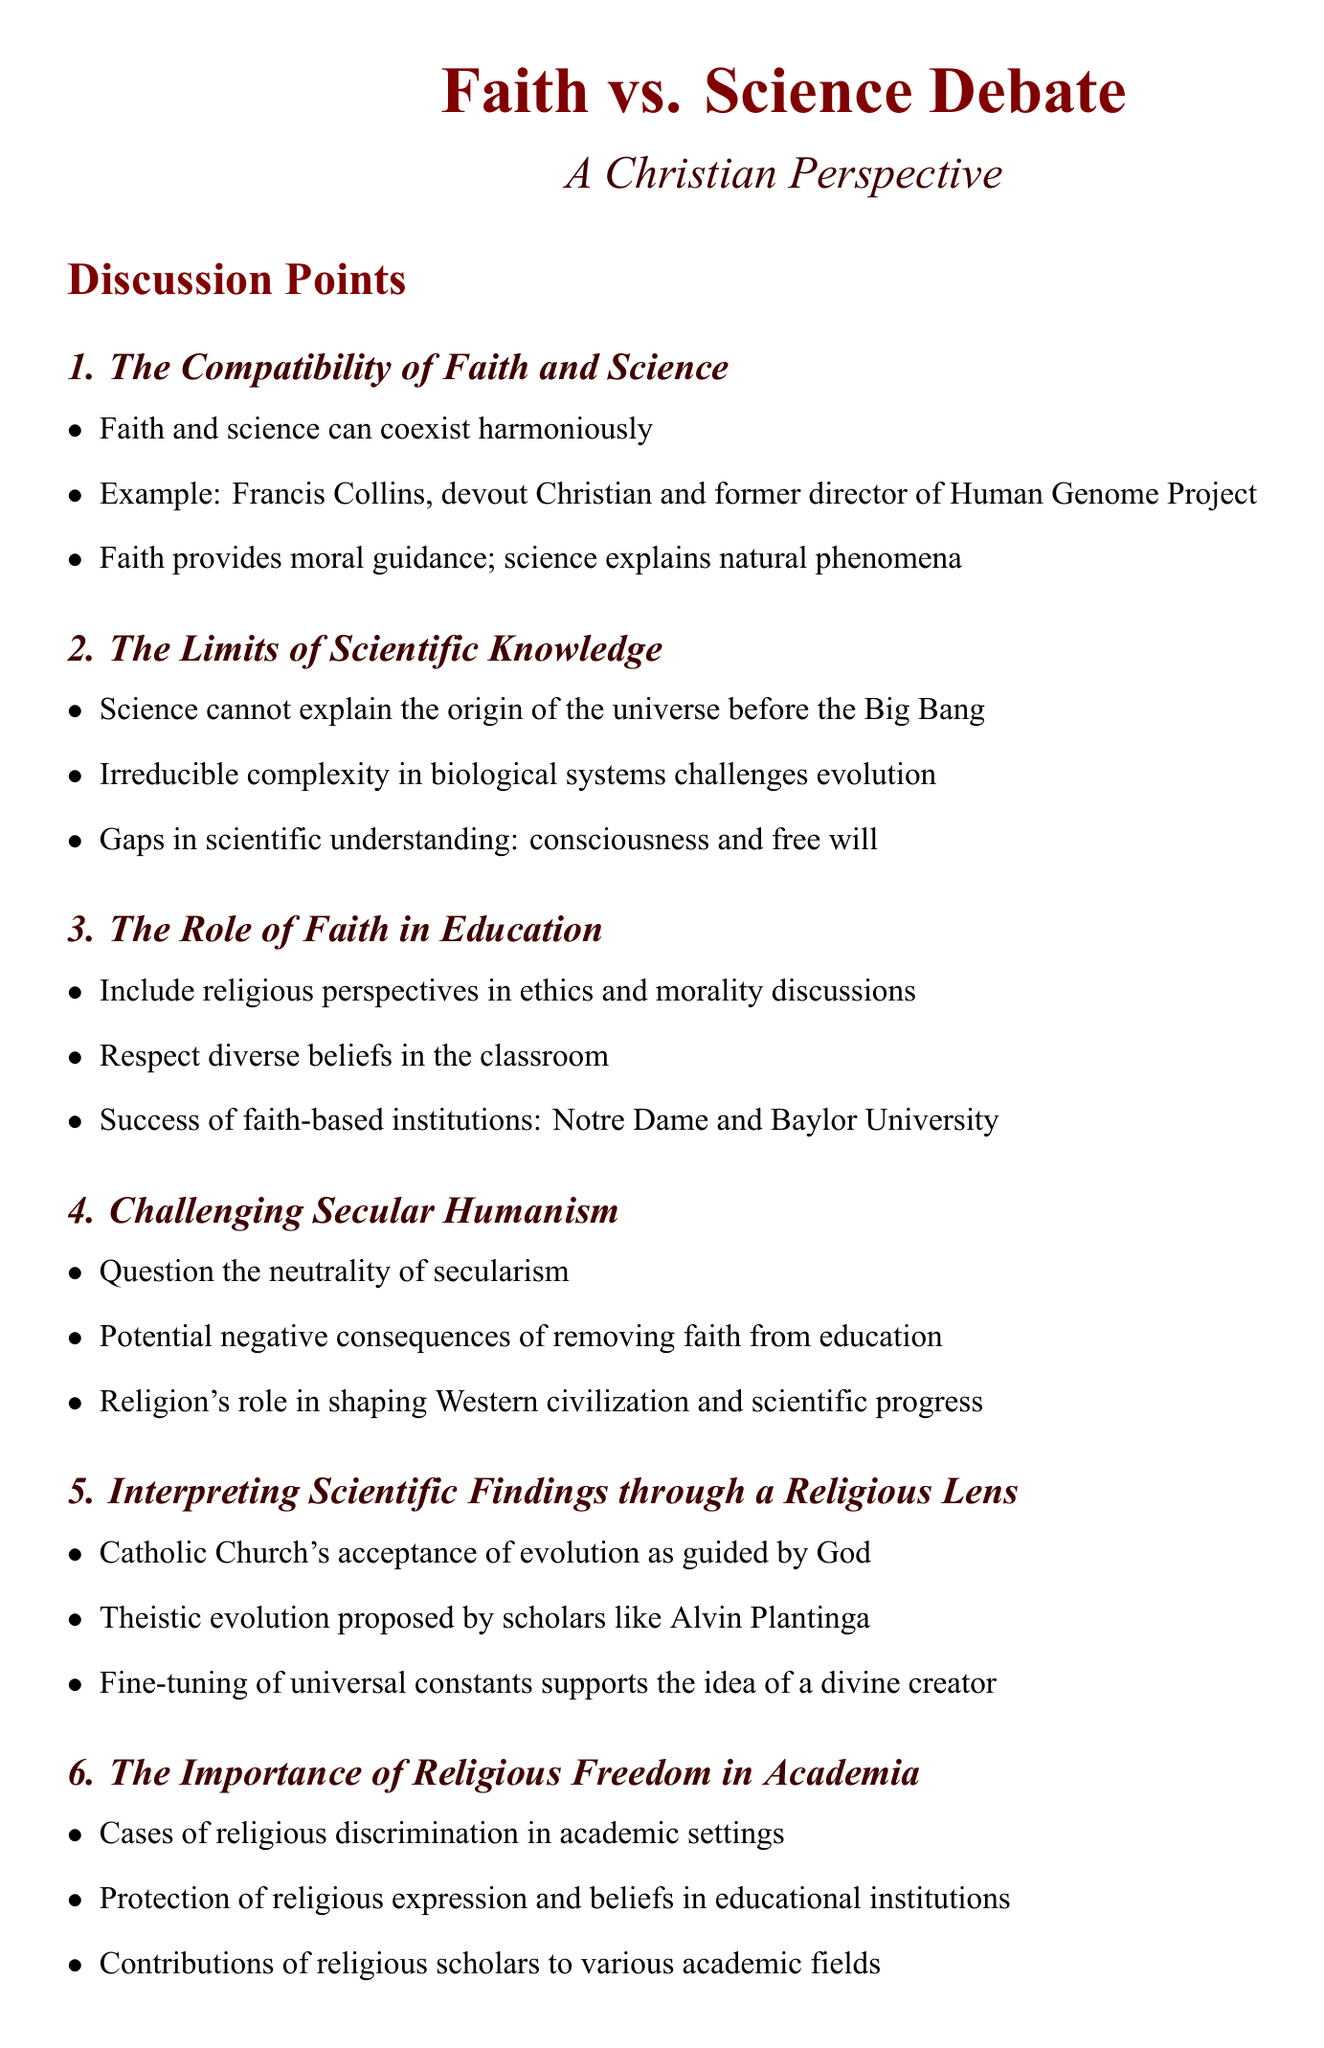What is the title of the first discussion point? The first discussion point is listed as "The Compatibility of Faith and Science".
Answer: The Compatibility of Faith and Science Who was the former director of the Human Genome Project mentioned in the document? The document provides the name of Francis Collins as the former director of the Human Genome Project.
Answer: Francis Collins What is highlighted as a successful faith-based educational institution? The document mentions Notre Dame as an example of a successful faith-based institution.
Answer: Notre Dame What concept challenges evolution according to the document? The document refers to "irreducible complexity" as a concept that challenges evolution.
Answer: Irreducible complexity Which section addresses religious discrimination in academic settings? The section titled "The Importance of Religious Freedom in Academia" discusses cases of religious discrimination.
Answer: The Importance of Religious Freedom in Academia What does the Catholic Church accept according to the discussion points? The document states that the Catholic Church accepts evolution as guided by God.
Answer: Evolution as guided by God Which scholar is associated with theistic evolution in the document? The document references Alvin Plantinga in relation to theistic evolution.
Answer: Alvin Plantinga What is questioned in the section "Challenging Secular Humanism"? The document questions the assumption that "secularism is neutral and unbiased".
Answer: Secularism is neutral and unbiased 